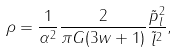<formula> <loc_0><loc_0><loc_500><loc_500>\rho = \frac { 1 } { \alpha ^ { 2 } } \frac { 2 } { \pi G ( 3 w + 1 ) } \frac { \tilde { p } _ { l } ^ { 2 } } { \tilde { l } ^ { 2 } } ,</formula> 